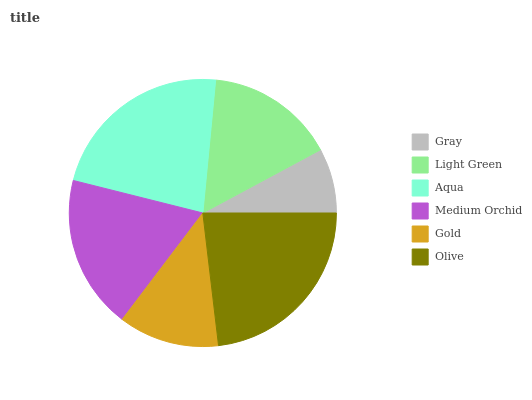Is Gray the minimum?
Answer yes or no. Yes. Is Olive the maximum?
Answer yes or no. Yes. Is Light Green the minimum?
Answer yes or no. No. Is Light Green the maximum?
Answer yes or no. No. Is Light Green greater than Gray?
Answer yes or no. Yes. Is Gray less than Light Green?
Answer yes or no. Yes. Is Gray greater than Light Green?
Answer yes or no. No. Is Light Green less than Gray?
Answer yes or no. No. Is Medium Orchid the high median?
Answer yes or no. Yes. Is Light Green the low median?
Answer yes or no. Yes. Is Gray the high median?
Answer yes or no. No. Is Medium Orchid the low median?
Answer yes or no. No. 